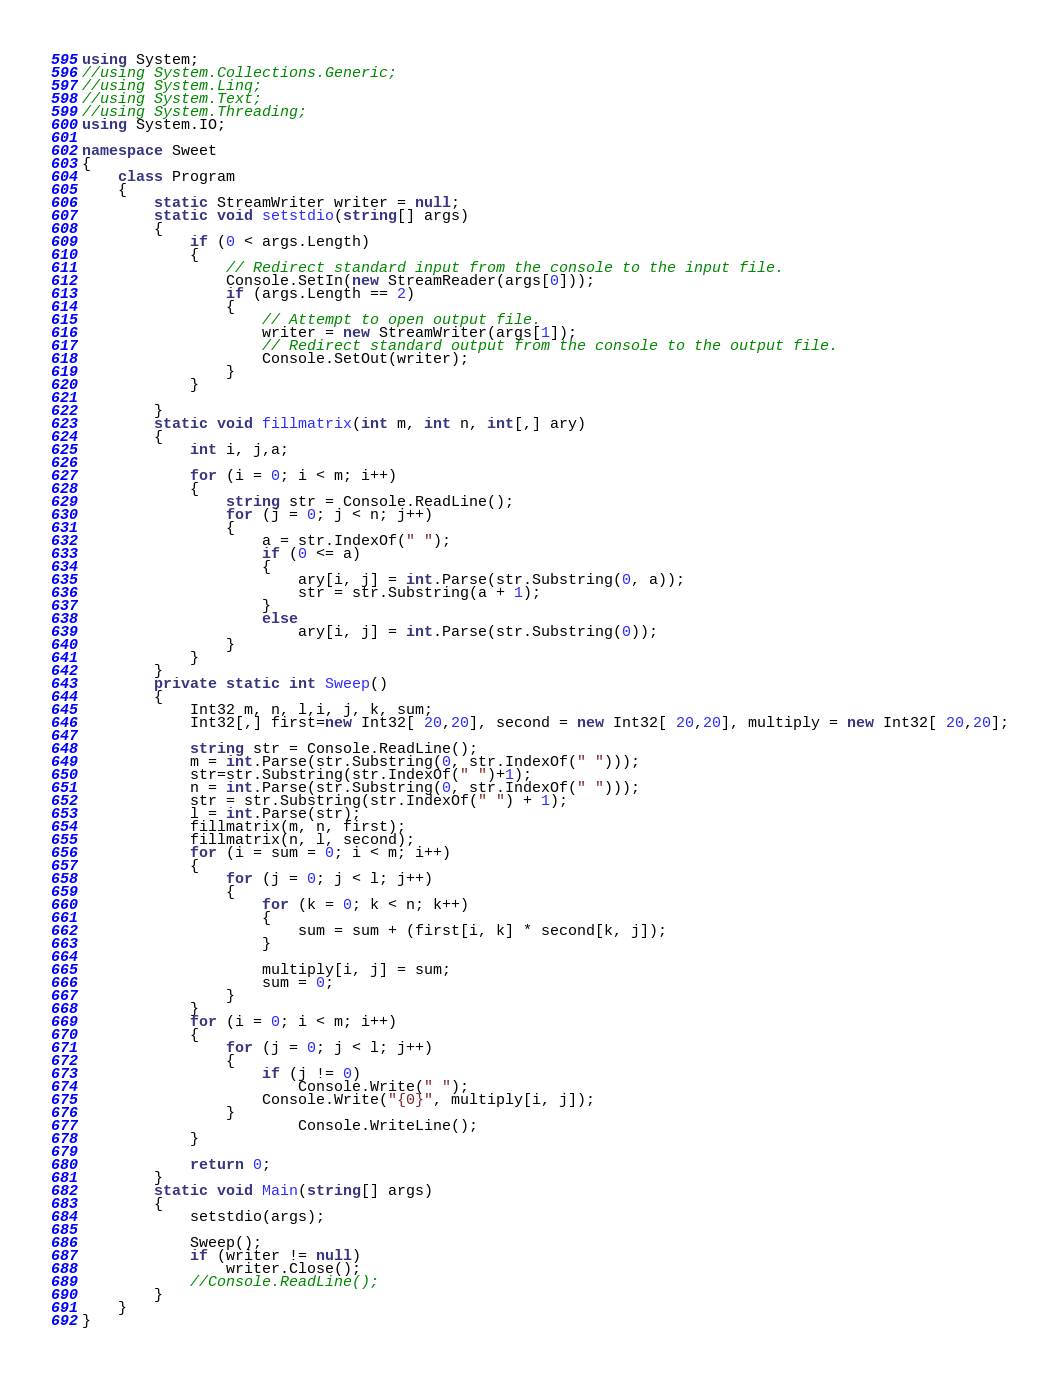<code> <loc_0><loc_0><loc_500><loc_500><_C#_>using System;
//using System.Collections.Generic;
//using System.Linq;
//using System.Text;
//using System.Threading;
using System.IO;

namespace Sweet
{
    class Program
    {
        static StreamWriter writer = null;
        static void setstdio(string[] args)
        {
            if (0 < args.Length)
            {
                // Redirect standard input from the console to the input file.
                Console.SetIn(new StreamReader(args[0]));
                if (args.Length == 2)
                {
                    // Attempt to open output file.
                    writer = new StreamWriter(args[1]);
                    // Redirect standard output from the console to the output file.
                    Console.SetOut(writer);
                }
            }

        }
        static void fillmatrix(int m, int n, int[,] ary)
        {
            int i, j,a;

            for (i = 0; i < m; i++)
            {
                string str = Console.ReadLine();
                for (j = 0; j < n; j++)
                {
                    a = str.IndexOf(" ");
                    if (0 <= a)
                    {
                        ary[i, j] = int.Parse(str.Substring(0, a));
                        str = str.Substring(a + 1);
                    }
                    else
                        ary[i, j] = int.Parse(str.Substring(0));
                }
            }
        }
        private static int Sweep()
        {
            Int32 m, n, l,i, j, k, sum;
            Int32[,] first=new Int32[ 20,20], second = new Int32[ 20,20], multiply = new Int32[ 20,20];

            string str = Console.ReadLine();
            m = int.Parse(str.Substring(0, str.IndexOf(" ")));
            str=str.Substring(str.IndexOf(" ")+1);
            n = int.Parse(str.Substring(0, str.IndexOf(" ")));
            str = str.Substring(str.IndexOf(" ") + 1);
            l = int.Parse(str);
            fillmatrix(m, n, first);
            fillmatrix(n, l, second);
            for (i = sum = 0; i < m; i++)
            {
                for (j = 0; j < l; j++)
                {
                    for (k = 0; k < n; k++)
                    {
                        sum = sum + (first[i, k] * second[k, j]);
                    }

                    multiply[i, j] = sum;
                    sum = 0;
                }
            }
            for (i = 0; i < m; i++)
            {
                for (j = 0; j < l; j++)
                {
                    if (j != 0)
                        Console.Write(" ");
                    Console.Write("{0}", multiply[i, j]);
                }
                        Console.WriteLine();
            }

            return 0;
        }
        static void Main(string[] args)
        {
            setstdio(args);

            Sweep();
            if (writer != null)
                writer.Close();
            //Console.ReadLine();
        }
    }
}</code> 